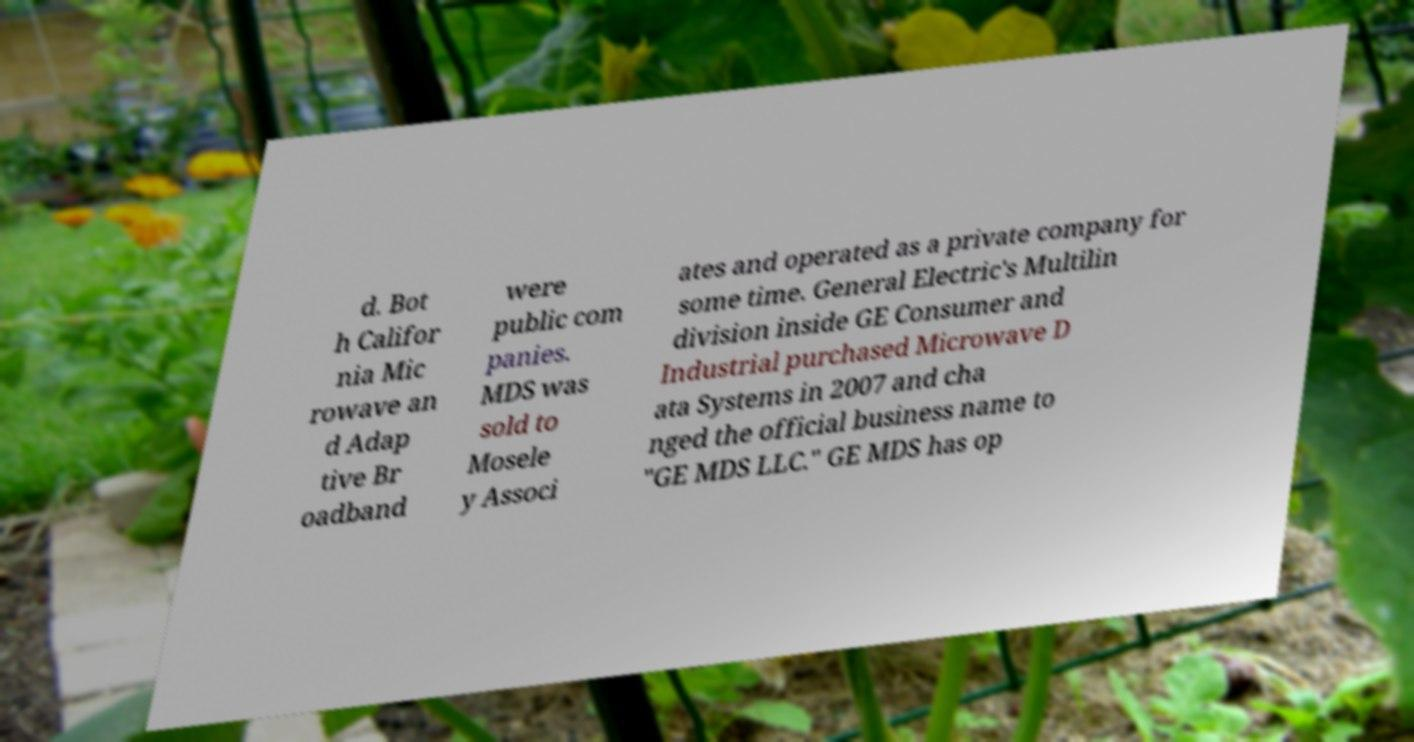What messages or text are displayed in this image? I need them in a readable, typed format. d. Bot h Califor nia Mic rowave an d Adap tive Br oadband were public com panies. MDS was sold to Mosele y Associ ates and operated as a private company for some time. General Electric's Multilin division inside GE Consumer and Industrial purchased Microwave D ata Systems in 2007 and cha nged the official business name to "GE MDS LLC." GE MDS has op 